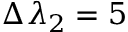Convert formula to latex. <formula><loc_0><loc_0><loc_500><loc_500>\Delta \lambda _ { 2 } = 5</formula> 